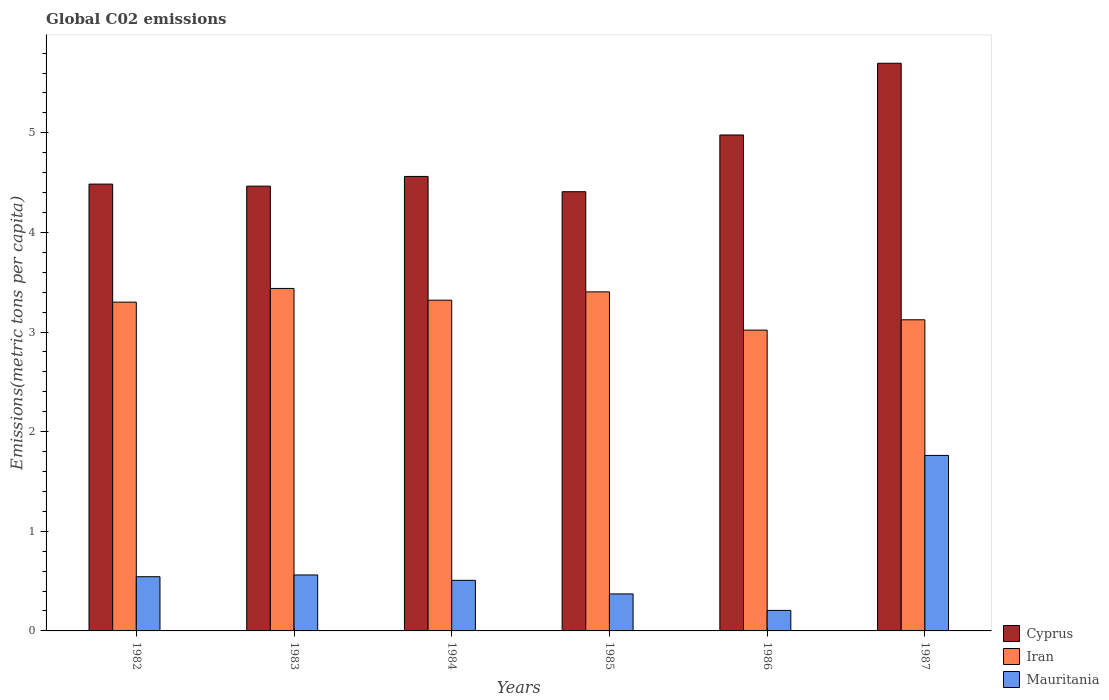How many groups of bars are there?
Ensure brevity in your answer.  6. Are the number of bars per tick equal to the number of legend labels?
Ensure brevity in your answer.  Yes. How many bars are there on the 6th tick from the right?
Your answer should be compact. 3. What is the amount of CO2 emitted in in Iran in 1987?
Keep it short and to the point. 3.12. Across all years, what is the maximum amount of CO2 emitted in in Cyprus?
Offer a terse response. 5.7. Across all years, what is the minimum amount of CO2 emitted in in Mauritania?
Provide a succinct answer. 0.21. What is the total amount of CO2 emitted in in Iran in the graph?
Your response must be concise. 19.6. What is the difference between the amount of CO2 emitted in in Mauritania in 1982 and that in 1984?
Ensure brevity in your answer.  0.04. What is the difference between the amount of CO2 emitted in in Iran in 1987 and the amount of CO2 emitted in in Cyprus in 1985?
Your answer should be compact. -1.29. What is the average amount of CO2 emitted in in Mauritania per year?
Offer a terse response. 0.66. In the year 1985, what is the difference between the amount of CO2 emitted in in Cyprus and amount of CO2 emitted in in Mauritania?
Ensure brevity in your answer.  4.04. In how many years, is the amount of CO2 emitted in in Cyprus greater than 1.4 metric tons per capita?
Give a very brief answer. 6. What is the ratio of the amount of CO2 emitted in in Mauritania in 1986 to that in 1987?
Offer a terse response. 0.12. What is the difference between the highest and the second highest amount of CO2 emitted in in Cyprus?
Ensure brevity in your answer.  0.72. What is the difference between the highest and the lowest amount of CO2 emitted in in Cyprus?
Ensure brevity in your answer.  1.29. What does the 3rd bar from the left in 1985 represents?
Provide a succinct answer. Mauritania. What does the 1st bar from the right in 1982 represents?
Keep it short and to the point. Mauritania. How many bars are there?
Ensure brevity in your answer.  18. Are all the bars in the graph horizontal?
Your response must be concise. No. How many years are there in the graph?
Ensure brevity in your answer.  6. What is the difference between two consecutive major ticks on the Y-axis?
Offer a very short reply. 1. Does the graph contain grids?
Provide a succinct answer. No. How are the legend labels stacked?
Make the answer very short. Vertical. What is the title of the graph?
Your answer should be compact. Global C02 emissions. Does "Grenada" appear as one of the legend labels in the graph?
Keep it short and to the point. No. What is the label or title of the X-axis?
Offer a very short reply. Years. What is the label or title of the Y-axis?
Offer a terse response. Emissions(metric tons per capita). What is the Emissions(metric tons per capita) in Cyprus in 1982?
Keep it short and to the point. 4.48. What is the Emissions(metric tons per capita) of Iran in 1982?
Make the answer very short. 3.3. What is the Emissions(metric tons per capita) of Mauritania in 1982?
Your answer should be very brief. 0.54. What is the Emissions(metric tons per capita) in Cyprus in 1983?
Provide a succinct answer. 4.46. What is the Emissions(metric tons per capita) of Iran in 1983?
Make the answer very short. 3.44. What is the Emissions(metric tons per capita) of Mauritania in 1983?
Keep it short and to the point. 0.56. What is the Emissions(metric tons per capita) of Cyprus in 1984?
Offer a very short reply. 4.56. What is the Emissions(metric tons per capita) in Iran in 1984?
Ensure brevity in your answer.  3.32. What is the Emissions(metric tons per capita) in Mauritania in 1984?
Offer a terse response. 0.51. What is the Emissions(metric tons per capita) in Cyprus in 1985?
Your answer should be compact. 4.41. What is the Emissions(metric tons per capita) in Iran in 1985?
Offer a terse response. 3.4. What is the Emissions(metric tons per capita) in Mauritania in 1985?
Offer a very short reply. 0.37. What is the Emissions(metric tons per capita) in Cyprus in 1986?
Provide a short and direct response. 4.98. What is the Emissions(metric tons per capita) in Iran in 1986?
Provide a succinct answer. 3.02. What is the Emissions(metric tons per capita) in Mauritania in 1986?
Your answer should be very brief. 0.21. What is the Emissions(metric tons per capita) of Cyprus in 1987?
Ensure brevity in your answer.  5.7. What is the Emissions(metric tons per capita) of Iran in 1987?
Your answer should be very brief. 3.12. What is the Emissions(metric tons per capita) in Mauritania in 1987?
Offer a terse response. 1.76. Across all years, what is the maximum Emissions(metric tons per capita) of Cyprus?
Provide a succinct answer. 5.7. Across all years, what is the maximum Emissions(metric tons per capita) of Iran?
Keep it short and to the point. 3.44. Across all years, what is the maximum Emissions(metric tons per capita) in Mauritania?
Make the answer very short. 1.76. Across all years, what is the minimum Emissions(metric tons per capita) of Cyprus?
Provide a succinct answer. 4.41. Across all years, what is the minimum Emissions(metric tons per capita) in Iran?
Offer a terse response. 3.02. Across all years, what is the minimum Emissions(metric tons per capita) in Mauritania?
Provide a short and direct response. 0.21. What is the total Emissions(metric tons per capita) of Cyprus in the graph?
Your answer should be compact. 28.6. What is the total Emissions(metric tons per capita) of Iran in the graph?
Provide a succinct answer. 19.6. What is the total Emissions(metric tons per capita) in Mauritania in the graph?
Your answer should be compact. 3.95. What is the difference between the Emissions(metric tons per capita) of Cyprus in 1982 and that in 1983?
Offer a very short reply. 0.02. What is the difference between the Emissions(metric tons per capita) in Iran in 1982 and that in 1983?
Ensure brevity in your answer.  -0.14. What is the difference between the Emissions(metric tons per capita) of Mauritania in 1982 and that in 1983?
Your answer should be compact. -0.02. What is the difference between the Emissions(metric tons per capita) in Cyprus in 1982 and that in 1984?
Make the answer very short. -0.08. What is the difference between the Emissions(metric tons per capita) in Iran in 1982 and that in 1984?
Provide a succinct answer. -0.02. What is the difference between the Emissions(metric tons per capita) of Mauritania in 1982 and that in 1984?
Offer a terse response. 0.04. What is the difference between the Emissions(metric tons per capita) of Cyprus in 1982 and that in 1985?
Your response must be concise. 0.08. What is the difference between the Emissions(metric tons per capita) in Iran in 1982 and that in 1985?
Keep it short and to the point. -0.1. What is the difference between the Emissions(metric tons per capita) of Mauritania in 1982 and that in 1985?
Provide a short and direct response. 0.17. What is the difference between the Emissions(metric tons per capita) in Cyprus in 1982 and that in 1986?
Provide a succinct answer. -0.49. What is the difference between the Emissions(metric tons per capita) of Iran in 1982 and that in 1986?
Provide a succinct answer. 0.28. What is the difference between the Emissions(metric tons per capita) of Mauritania in 1982 and that in 1986?
Offer a very short reply. 0.34. What is the difference between the Emissions(metric tons per capita) in Cyprus in 1982 and that in 1987?
Offer a very short reply. -1.21. What is the difference between the Emissions(metric tons per capita) of Iran in 1982 and that in 1987?
Your answer should be very brief. 0.18. What is the difference between the Emissions(metric tons per capita) of Mauritania in 1982 and that in 1987?
Your answer should be compact. -1.22. What is the difference between the Emissions(metric tons per capita) in Cyprus in 1983 and that in 1984?
Ensure brevity in your answer.  -0.1. What is the difference between the Emissions(metric tons per capita) in Iran in 1983 and that in 1984?
Your answer should be compact. 0.12. What is the difference between the Emissions(metric tons per capita) of Mauritania in 1983 and that in 1984?
Give a very brief answer. 0.05. What is the difference between the Emissions(metric tons per capita) of Cyprus in 1983 and that in 1985?
Provide a short and direct response. 0.06. What is the difference between the Emissions(metric tons per capita) of Iran in 1983 and that in 1985?
Offer a terse response. 0.03. What is the difference between the Emissions(metric tons per capita) of Mauritania in 1983 and that in 1985?
Provide a short and direct response. 0.19. What is the difference between the Emissions(metric tons per capita) in Cyprus in 1983 and that in 1986?
Keep it short and to the point. -0.51. What is the difference between the Emissions(metric tons per capita) of Iran in 1983 and that in 1986?
Your answer should be compact. 0.42. What is the difference between the Emissions(metric tons per capita) in Mauritania in 1983 and that in 1986?
Make the answer very short. 0.36. What is the difference between the Emissions(metric tons per capita) of Cyprus in 1983 and that in 1987?
Ensure brevity in your answer.  -1.23. What is the difference between the Emissions(metric tons per capita) in Iran in 1983 and that in 1987?
Provide a succinct answer. 0.31. What is the difference between the Emissions(metric tons per capita) in Mauritania in 1983 and that in 1987?
Provide a short and direct response. -1.2. What is the difference between the Emissions(metric tons per capita) of Cyprus in 1984 and that in 1985?
Provide a short and direct response. 0.15. What is the difference between the Emissions(metric tons per capita) of Iran in 1984 and that in 1985?
Your answer should be very brief. -0.08. What is the difference between the Emissions(metric tons per capita) in Mauritania in 1984 and that in 1985?
Provide a succinct answer. 0.14. What is the difference between the Emissions(metric tons per capita) in Cyprus in 1984 and that in 1986?
Offer a very short reply. -0.42. What is the difference between the Emissions(metric tons per capita) in Iran in 1984 and that in 1986?
Offer a very short reply. 0.3. What is the difference between the Emissions(metric tons per capita) in Mauritania in 1984 and that in 1986?
Make the answer very short. 0.3. What is the difference between the Emissions(metric tons per capita) in Cyprus in 1984 and that in 1987?
Offer a very short reply. -1.14. What is the difference between the Emissions(metric tons per capita) in Iran in 1984 and that in 1987?
Your answer should be compact. 0.2. What is the difference between the Emissions(metric tons per capita) in Mauritania in 1984 and that in 1987?
Your answer should be compact. -1.25. What is the difference between the Emissions(metric tons per capita) of Cyprus in 1985 and that in 1986?
Give a very brief answer. -0.57. What is the difference between the Emissions(metric tons per capita) of Iran in 1985 and that in 1986?
Make the answer very short. 0.38. What is the difference between the Emissions(metric tons per capita) of Mauritania in 1985 and that in 1986?
Ensure brevity in your answer.  0.17. What is the difference between the Emissions(metric tons per capita) of Cyprus in 1985 and that in 1987?
Give a very brief answer. -1.29. What is the difference between the Emissions(metric tons per capita) in Iran in 1985 and that in 1987?
Make the answer very short. 0.28. What is the difference between the Emissions(metric tons per capita) in Mauritania in 1985 and that in 1987?
Make the answer very short. -1.39. What is the difference between the Emissions(metric tons per capita) of Cyprus in 1986 and that in 1987?
Provide a succinct answer. -0.72. What is the difference between the Emissions(metric tons per capita) of Iran in 1986 and that in 1987?
Provide a succinct answer. -0.1. What is the difference between the Emissions(metric tons per capita) in Mauritania in 1986 and that in 1987?
Provide a short and direct response. -1.56. What is the difference between the Emissions(metric tons per capita) in Cyprus in 1982 and the Emissions(metric tons per capita) in Iran in 1983?
Offer a terse response. 1.05. What is the difference between the Emissions(metric tons per capita) in Cyprus in 1982 and the Emissions(metric tons per capita) in Mauritania in 1983?
Offer a terse response. 3.92. What is the difference between the Emissions(metric tons per capita) in Iran in 1982 and the Emissions(metric tons per capita) in Mauritania in 1983?
Offer a terse response. 2.74. What is the difference between the Emissions(metric tons per capita) in Cyprus in 1982 and the Emissions(metric tons per capita) in Iran in 1984?
Your answer should be very brief. 1.17. What is the difference between the Emissions(metric tons per capita) of Cyprus in 1982 and the Emissions(metric tons per capita) of Mauritania in 1984?
Ensure brevity in your answer.  3.98. What is the difference between the Emissions(metric tons per capita) in Iran in 1982 and the Emissions(metric tons per capita) in Mauritania in 1984?
Offer a very short reply. 2.79. What is the difference between the Emissions(metric tons per capita) of Cyprus in 1982 and the Emissions(metric tons per capita) of Iran in 1985?
Give a very brief answer. 1.08. What is the difference between the Emissions(metric tons per capita) in Cyprus in 1982 and the Emissions(metric tons per capita) in Mauritania in 1985?
Provide a succinct answer. 4.11. What is the difference between the Emissions(metric tons per capita) of Iran in 1982 and the Emissions(metric tons per capita) of Mauritania in 1985?
Keep it short and to the point. 2.93. What is the difference between the Emissions(metric tons per capita) in Cyprus in 1982 and the Emissions(metric tons per capita) in Iran in 1986?
Your answer should be compact. 1.47. What is the difference between the Emissions(metric tons per capita) of Cyprus in 1982 and the Emissions(metric tons per capita) of Mauritania in 1986?
Make the answer very short. 4.28. What is the difference between the Emissions(metric tons per capita) of Iran in 1982 and the Emissions(metric tons per capita) of Mauritania in 1986?
Ensure brevity in your answer.  3.09. What is the difference between the Emissions(metric tons per capita) in Cyprus in 1982 and the Emissions(metric tons per capita) in Iran in 1987?
Provide a succinct answer. 1.36. What is the difference between the Emissions(metric tons per capita) of Cyprus in 1982 and the Emissions(metric tons per capita) of Mauritania in 1987?
Provide a short and direct response. 2.72. What is the difference between the Emissions(metric tons per capita) in Iran in 1982 and the Emissions(metric tons per capita) in Mauritania in 1987?
Offer a terse response. 1.54. What is the difference between the Emissions(metric tons per capita) in Cyprus in 1983 and the Emissions(metric tons per capita) in Iran in 1984?
Provide a succinct answer. 1.14. What is the difference between the Emissions(metric tons per capita) of Cyprus in 1983 and the Emissions(metric tons per capita) of Mauritania in 1984?
Keep it short and to the point. 3.96. What is the difference between the Emissions(metric tons per capita) in Iran in 1983 and the Emissions(metric tons per capita) in Mauritania in 1984?
Ensure brevity in your answer.  2.93. What is the difference between the Emissions(metric tons per capita) in Cyprus in 1983 and the Emissions(metric tons per capita) in Iran in 1985?
Your answer should be compact. 1.06. What is the difference between the Emissions(metric tons per capita) in Cyprus in 1983 and the Emissions(metric tons per capita) in Mauritania in 1985?
Your answer should be compact. 4.09. What is the difference between the Emissions(metric tons per capita) in Iran in 1983 and the Emissions(metric tons per capita) in Mauritania in 1985?
Offer a very short reply. 3.07. What is the difference between the Emissions(metric tons per capita) in Cyprus in 1983 and the Emissions(metric tons per capita) in Iran in 1986?
Your answer should be very brief. 1.45. What is the difference between the Emissions(metric tons per capita) of Cyprus in 1983 and the Emissions(metric tons per capita) of Mauritania in 1986?
Provide a succinct answer. 4.26. What is the difference between the Emissions(metric tons per capita) of Iran in 1983 and the Emissions(metric tons per capita) of Mauritania in 1986?
Your response must be concise. 3.23. What is the difference between the Emissions(metric tons per capita) in Cyprus in 1983 and the Emissions(metric tons per capita) in Iran in 1987?
Ensure brevity in your answer.  1.34. What is the difference between the Emissions(metric tons per capita) in Cyprus in 1983 and the Emissions(metric tons per capita) in Mauritania in 1987?
Make the answer very short. 2.7. What is the difference between the Emissions(metric tons per capita) in Iran in 1983 and the Emissions(metric tons per capita) in Mauritania in 1987?
Your answer should be very brief. 1.68. What is the difference between the Emissions(metric tons per capita) of Cyprus in 1984 and the Emissions(metric tons per capita) of Iran in 1985?
Offer a terse response. 1.16. What is the difference between the Emissions(metric tons per capita) in Cyprus in 1984 and the Emissions(metric tons per capita) in Mauritania in 1985?
Offer a very short reply. 4.19. What is the difference between the Emissions(metric tons per capita) in Iran in 1984 and the Emissions(metric tons per capita) in Mauritania in 1985?
Your answer should be very brief. 2.95. What is the difference between the Emissions(metric tons per capita) in Cyprus in 1984 and the Emissions(metric tons per capita) in Iran in 1986?
Your answer should be compact. 1.54. What is the difference between the Emissions(metric tons per capita) in Cyprus in 1984 and the Emissions(metric tons per capita) in Mauritania in 1986?
Give a very brief answer. 4.36. What is the difference between the Emissions(metric tons per capita) of Iran in 1984 and the Emissions(metric tons per capita) of Mauritania in 1986?
Provide a succinct answer. 3.11. What is the difference between the Emissions(metric tons per capita) in Cyprus in 1984 and the Emissions(metric tons per capita) in Iran in 1987?
Your answer should be compact. 1.44. What is the difference between the Emissions(metric tons per capita) in Cyprus in 1984 and the Emissions(metric tons per capita) in Mauritania in 1987?
Your answer should be compact. 2.8. What is the difference between the Emissions(metric tons per capita) of Iran in 1984 and the Emissions(metric tons per capita) of Mauritania in 1987?
Give a very brief answer. 1.56. What is the difference between the Emissions(metric tons per capita) in Cyprus in 1985 and the Emissions(metric tons per capita) in Iran in 1986?
Keep it short and to the point. 1.39. What is the difference between the Emissions(metric tons per capita) in Cyprus in 1985 and the Emissions(metric tons per capita) in Mauritania in 1986?
Ensure brevity in your answer.  4.2. What is the difference between the Emissions(metric tons per capita) in Iran in 1985 and the Emissions(metric tons per capita) in Mauritania in 1986?
Make the answer very short. 3.2. What is the difference between the Emissions(metric tons per capita) of Cyprus in 1985 and the Emissions(metric tons per capita) of Mauritania in 1987?
Make the answer very short. 2.65. What is the difference between the Emissions(metric tons per capita) in Iran in 1985 and the Emissions(metric tons per capita) in Mauritania in 1987?
Your response must be concise. 1.64. What is the difference between the Emissions(metric tons per capita) in Cyprus in 1986 and the Emissions(metric tons per capita) in Iran in 1987?
Keep it short and to the point. 1.86. What is the difference between the Emissions(metric tons per capita) of Cyprus in 1986 and the Emissions(metric tons per capita) of Mauritania in 1987?
Ensure brevity in your answer.  3.22. What is the difference between the Emissions(metric tons per capita) in Iran in 1986 and the Emissions(metric tons per capita) in Mauritania in 1987?
Provide a succinct answer. 1.26. What is the average Emissions(metric tons per capita) of Cyprus per year?
Give a very brief answer. 4.77. What is the average Emissions(metric tons per capita) of Iran per year?
Offer a terse response. 3.27. What is the average Emissions(metric tons per capita) in Mauritania per year?
Keep it short and to the point. 0.66. In the year 1982, what is the difference between the Emissions(metric tons per capita) in Cyprus and Emissions(metric tons per capita) in Iran?
Your answer should be very brief. 1.18. In the year 1982, what is the difference between the Emissions(metric tons per capita) of Cyprus and Emissions(metric tons per capita) of Mauritania?
Your answer should be very brief. 3.94. In the year 1982, what is the difference between the Emissions(metric tons per capita) in Iran and Emissions(metric tons per capita) in Mauritania?
Your response must be concise. 2.76. In the year 1983, what is the difference between the Emissions(metric tons per capita) in Cyprus and Emissions(metric tons per capita) in Iran?
Ensure brevity in your answer.  1.03. In the year 1983, what is the difference between the Emissions(metric tons per capita) in Cyprus and Emissions(metric tons per capita) in Mauritania?
Give a very brief answer. 3.9. In the year 1983, what is the difference between the Emissions(metric tons per capita) of Iran and Emissions(metric tons per capita) of Mauritania?
Give a very brief answer. 2.88. In the year 1984, what is the difference between the Emissions(metric tons per capita) in Cyprus and Emissions(metric tons per capita) in Iran?
Give a very brief answer. 1.24. In the year 1984, what is the difference between the Emissions(metric tons per capita) in Cyprus and Emissions(metric tons per capita) in Mauritania?
Make the answer very short. 4.05. In the year 1984, what is the difference between the Emissions(metric tons per capita) in Iran and Emissions(metric tons per capita) in Mauritania?
Your answer should be very brief. 2.81. In the year 1985, what is the difference between the Emissions(metric tons per capita) of Cyprus and Emissions(metric tons per capita) of Iran?
Offer a very short reply. 1.01. In the year 1985, what is the difference between the Emissions(metric tons per capita) in Cyprus and Emissions(metric tons per capita) in Mauritania?
Ensure brevity in your answer.  4.04. In the year 1985, what is the difference between the Emissions(metric tons per capita) in Iran and Emissions(metric tons per capita) in Mauritania?
Provide a succinct answer. 3.03. In the year 1986, what is the difference between the Emissions(metric tons per capita) of Cyprus and Emissions(metric tons per capita) of Iran?
Make the answer very short. 1.96. In the year 1986, what is the difference between the Emissions(metric tons per capita) of Cyprus and Emissions(metric tons per capita) of Mauritania?
Your answer should be very brief. 4.77. In the year 1986, what is the difference between the Emissions(metric tons per capita) in Iran and Emissions(metric tons per capita) in Mauritania?
Make the answer very short. 2.81. In the year 1987, what is the difference between the Emissions(metric tons per capita) in Cyprus and Emissions(metric tons per capita) in Iran?
Your answer should be very brief. 2.58. In the year 1987, what is the difference between the Emissions(metric tons per capita) in Cyprus and Emissions(metric tons per capita) in Mauritania?
Give a very brief answer. 3.94. In the year 1987, what is the difference between the Emissions(metric tons per capita) of Iran and Emissions(metric tons per capita) of Mauritania?
Give a very brief answer. 1.36. What is the ratio of the Emissions(metric tons per capita) of Iran in 1982 to that in 1983?
Keep it short and to the point. 0.96. What is the ratio of the Emissions(metric tons per capita) in Mauritania in 1982 to that in 1983?
Offer a very short reply. 0.97. What is the ratio of the Emissions(metric tons per capita) in Cyprus in 1982 to that in 1984?
Your answer should be very brief. 0.98. What is the ratio of the Emissions(metric tons per capita) in Mauritania in 1982 to that in 1984?
Your answer should be very brief. 1.07. What is the ratio of the Emissions(metric tons per capita) in Cyprus in 1982 to that in 1985?
Ensure brevity in your answer.  1.02. What is the ratio of the Emissions(metric tons per capita) in Iran in 1982 to that in 1985?
Provide a short and direct response. 0.97. What is the ratio of the Emissions(metric tons per capita) in Mauritania in 1982 to that in 1985?
Provide a short and direct response. 1.46. What is the ratio of the Emissions(metric tons per capita) in Cyprus in 1982 to that in 1986?
Give a very brief answer. 0.9. What is the ratio of the Emissions(metric tons per capita) in Iran in 1982 to that in 1986?
Your answer should be very brief. 1.09. What is the ratio of the Emissions(metric tons per capita) of Mauritania in 1982 to that in 1986?
Provide a short and direct response. 2.64. What is the ratio of the Emissions(metric tons per capita) of Cyprus in 1982 to that in 1987?
Your answer should be compact. 0.79. What is the ratio of the Emissions(metric tons per capita) of Iran in 1982 to that in 1987?
Offer a very short reply. 1.06. What is the ratio of the Emissions(metric tons per capita) in Mauritania in 1982 to that in 1987?
Give a very brief answer. 0.31. What is the ratio of the Emissions(metric tons per capita) of Cyprus in 1983 to that in 1984?
Keep it short and to the point. 0.98. What is the ratio of the Emissions(metric tons per capita) of Iran in 1983 to that in 1984?
Provide a succinct answer. 1.04. What is the ratio of the Emissions(metric tons per capita) in Mauritania in 1983 to that in 1984?
Your response must be concise. 1.11. What is the ratio of the Emissions(metric tons per capita) of Cyprus in 1983 to that in 1985?
Provide a succinct answer. 1.01. What is the ratio of the Emissions(metric tons per capita) of Iran in 1983 to that in 1985?
Keep it short and to the point. 1.01. What is the ratio of the Emissions(metric tons per capita) of Mauritania in 1983 to that in 1985?
Make the answer very short. 1.51. What is the ratio of the Emissions(metric tons per capita) in Cyprus in 1983 to that in 1986?
Your response must be concise. 0.9. What is the ratio of the Emissions(metric tons per capita) of Iran in 1983 to that in 1986?
Make the answer very short. 1.14. What is the ratio of the Emissions(metric tons per capita) of Mauritania in 1983 to that in 1986?
Give a very brief answer. 2.73. What is the ratio of the Emissions(metric tons per capita) of Cyprus in 1983 to that in 1987?
Provide a short and direct response. 0.78. What is the ratio of the Emissions(metric tons per capita) in Iran in 1983 to that in 1987?
Ensure brevity in your answer.  1.1. What is the ratio of the Emissions(metric tons per capita) of Mauritania in 1983 to that in 1987?
Provide a short and direct response. 0.32. What is the ratio of the Emissions(metric tons per capita) of Cyprus in 1984 to that in 1985?
Ensure brevity in your answer.  1.03. What is the ratio of the Emissions(metric tons per capita) in Iran in 1984 to that in 1985?
Give a very brief answer. 0.98. What is the ratio of the Emissions(metric tons per capita) in Mauritania in 1984 to that in 1985?
Make the answer very short. 1.37. What is the ratio of the Emissions(metric tons per capita) in Cyprus in 1984 to that in 1986?
Your response must be concise. 0.92. What is the ratio of the Emissions(metric tons per capita) in Iran in 1984 to that in 1986?
Offer a terse response. 1.1. What is the ratio of the Emissions(metric tons per capita) in Mauritania in 1984 to that in 1986?
Give a very brief answer. 2.47. What is the ratio of the Emissions(metric tons per capita) in Cyprus in 1984 to that in 1987?
Offer a very short reply. 0.8. What is the ratio of the Emissions(metric tons per capita) of Iran in 1984 to that in 1987?
Give a very brief answer. 1.06. What is the ratio of the Emissions(metric tons per capita) in Mauritania in 1984 to that in 1987?
Provide a short and direct response. 0.29. What is the ratio of the Emissions(metric tons per capita) in Cyprus in 1985 to that in 1986?
Offer a terse response. 0.89. What is the ratio of the Emissions(metric tons per capita) in Iran in 1985 to that in 1986?
Make the answer very short. 1.13. What is the ratio of the Emissions(metric tons per capita) of Mauritania in 1985 to that in 1986?
Your answer should be compact. 1.8. What is the ratio of the Emissions(metric tons per capita) in Cyprus in 1985 to that in 1987?
Provide a short and direct response. 0.77. What is the ratio of the Emissions(metric tons per capita) of Iran in 1985 to that in 1987?
Offer a terse response. 1.09. What is the ratio of the Emissions(metric tons per capita) in Mauritania in 1985 to that in 1987?
Give a very brief answer. 0.21. What is the ratio of the Emissions(metric tons per capita) of Cyprus in 1986 to that in 1987?
Provide a short and direct response. 0.87. What is the ratio of the Emissions(metric tons per capita) of Iran in 1986 to that in 1987?
Keep it short and to the point. 0.97. What is the ratio of the Emissions(metric tons per capita) in Mauritania in 1986 to that in 1987?
Make the answer very short. 0.12. What is the difference between the highest and the second highest Emissions(metric tons per capita) of Cyprus?
Provide a succinct answer. 0.72. What is the difference between the highest and the second highest Emissions(metric tons per capita) of Iran?
Provide a succinct answer. 0.03. What is the difference between the highest and the second highest Emissions(metric tons per capita) of Mauritania?
Your answer should be compact. 1.2. What is the difference between the highest and the lowest Emissions(metric tons per capita) of Cyprus?
Your response must be concise. 1.29. What is the difference between the highest and the lowest Emissions(metric tons per capita) of Iran?
Make the answer very short. 0.42. What is the difference between the highest and the lowest Emissions(metric tons per capita) of Mauritania?
Ensure brevity in your answer.  1.56. 